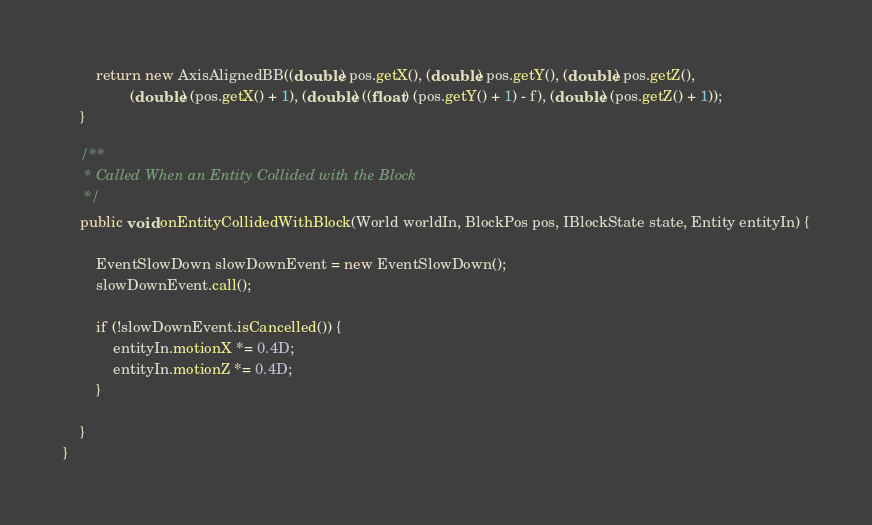Convert code to text. <code><loc_0><loc_0><loc_500><loc_500><_Java_>		return new AxisAlignedBB((double) pos.getX(), (double) pos.getY(), (double) pos.getZ(),
				(double) (pos.getX() + 1), (double) ((float) (pos.getY() + 1) - f), (double) (pos.getZ() + 1));
	}

	/**
	 * Called When an Entity Collided with the Block
	 */
	public void onEntityCollidedWithBlock(World worldIn, BlockPos pos, IBlockState state, Entity entityIn) {

		EventSlowDown slowDownEvent = new EventSlowDown();
		slowDownEvent.call();

		if (!slowDownEvent.isCancelled()) {
			entityIn.motionX *= 0.4D;
			entityIn.motionZ *= 0.4D;
		}

	}
}
</code> 